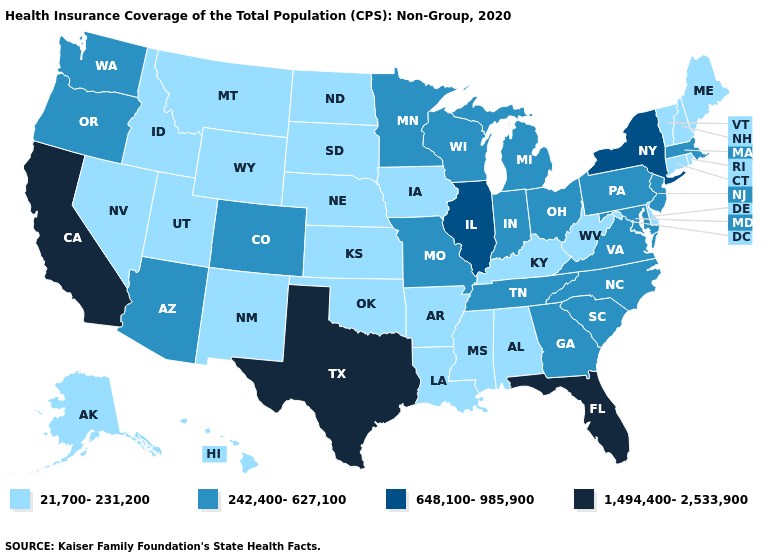What is the value of Kentucky?
Short answer required. 21,700-231,200. Which states have the lowest value in the USA?
Give a very brief answer. Alabama, Alaska, Arkansas, Connecticut, Delaware, Hawaii, Idaho, Iowa, Kansas, Kentucky, Louisiana, Maine, Mississippi, Montana, Nebraska, Nevada, New Hampshire, New Mexico, North Dakota, Oklahoma, Rhode Island, South Dakota, Utah, Vermont, West Virginia, Wyoming. Name the states that have a value in the range 648,100-985,900?
Give a very brief answer. Illinois, New York. What is the value of Ohio?
Quick response, please. 242,400-627,100. Which states hav the highest value in the West?
Write a very short answer. California. What is the highest value in states that border Indiana?
Give a very brief answer. 648,100-985,900. Does the first symbol in the legend represent the smallest category?
Give a very brief answer. Yes. What is the lowest value in states that border Maryland?
Concise answer only. 21,700-231,200. What is the value of Louisiana?
Quick response, please. 21,700-231,200. Does Mississippi have the lowest value in the South?
Short answer required. Yes. Name the states that have a value in the range 21,700-231,200?
Give a very brief answer. Alabama, Alaska, Arkansas, Connecticut, Delaware, Hawaii, Idaho, Iowa, Kansas, Kentucky, Louisiana, Maine, Mississippi, Montana, Nebraska, Nevada, New Hampshire, New Mexico, North Dakota, Oklahoma, Rhode Island, South Dakota, Utah, Vermont, West Virginia, Wyoming. Which states have the lowest value in the South?
Write a very short answer. Alabama, Arkansas, Delaware, Kentucky, Louisiana, Mississippi, Oklahoma, West Virginia. What is the value of Louisiana?
Short answer required. 21,700-231,200. What is the value of Missouri?
Give a very brief answer. 242,400-627,100. 